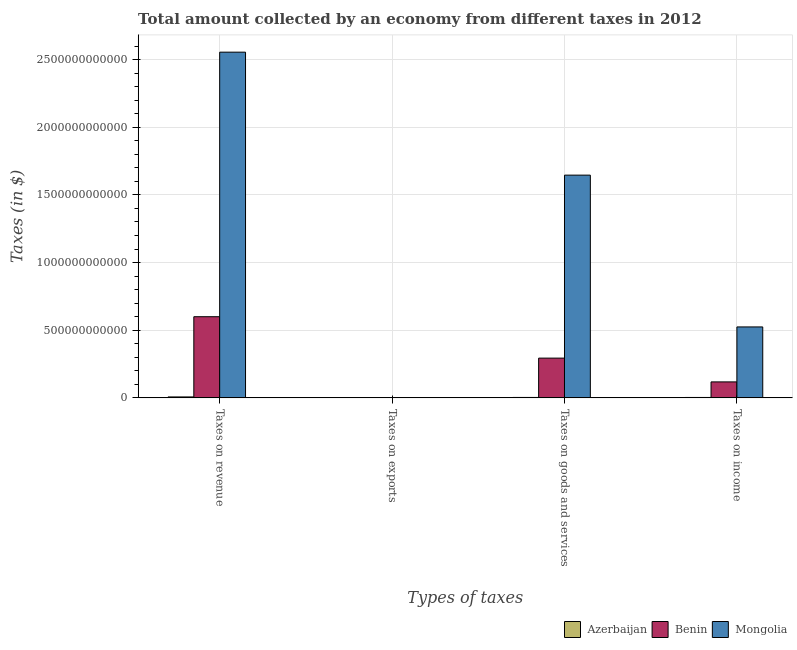How many different coloured bars are there?
Provide a succinct answer. 3. What is the label of the 4th group of bars from the left?
Ensure brevity in your answer.  Taxes on income. What is the amount collected as tax on exports in Azerbaijan?
Provide a short and direct response. 8.00e+05. Across all countries, what is the maximum amount collected as tax on exports?
Your answer should be compact. 4.79e+08. Across all countries, what is the minimum amount collected as tax on revenue?
Provide a succinct answer. 7.00e+09. In which country was the amount collected as tax on income maximum?
Offer a very short reply. Mongolia. In which country was the amount collected as tax on revenue minimum?
Ensure brevity in your answer.  Azerbaijan. What is the total amount collected as tax on income in the graph?
Offer a very short reply. 6.46e+11. What is the difference between the amount collected as tax on exports in Benin and that in Mongolia?
Provide a short and direct response. 2.84e+08. What is the difference between the amount collected as tax on income in Mongolia and the amount collected as tax on goods in Azerbaijan?
Provide a succinct answer. 5.21e+11. What is the average amount collected as tax on goods per country?
Give a very brief answer. 6.48e+11. What is the difference between the amount collected as tax on goods and amount collected as tax on exports in Benin?
Your answer should be compact. 2.93e+11. In how many countries, is the amount collected as tax on goods greater than 1700000000000 $?
Your response must be concise. 0. What is the ratio of the amount collected as tax on revenue in Benin to that in Azerbaijan?
Your answer should be compact. 85.76. Is the amount collected as tax on income in Benin less than that in Mongolia?
Provide a short and direct response. Yes. What is the difference between the highest and the second highest amount collected as tax on revenue?
Provide a succinct answer. 1.96e+12. What is the difference between the highest and the lowest amount collected as tax on exports?
Make the answer very short. 4.79e+08. Is the sum of the amount collected as tax on exports in Benin and Azerbaijan greater than the maximum amount collected as tax on income across all countries?
Offer a very short reply. No. What does the 3rd bar from the left in Taxes on income represents?
Give a very brief answer. Mongolia. What does the 3rd bar from the right in Taxes on exports represents?
Your answer should be very brief. Azerbaijan. Is it the case that in every country, the sum of the amount collected as tax on revenue and amount collected as tax on exports is greater than the amount collected as tax on goods?
Your response must be concise. Yes. How many countries are there in the graph?
Provide a short and direct response. 3. What is the difference between two consecutive major ticks on the Y-axis?
Ensure brevity in your answer.  5.00e+11. Are the values on the major ticks of Y-axis written in scientific E-notation?
Your answer should be very brief. No. Does the graph contain any zero values?
Your answer should be very brief. No. Does the graph contain grids?
Provide a short and direct response. Yes. How many legend labels are there?
Ensure brevity in your answer.  3. What is the title of the graph?
Make the answer very short. Total amount collected by an economy from different taxes in 2012. What is the label or title of the X-axis?
Keep it short and to the point. Types of taxes. What is the label or title of the Y-axis?
Provide a short and direct response. Taxes (in $). What is the Taxes (in $) in Azerbaijan in Taxes on revenue?
Your answer should be compact. 7.00e+09. What is the Taxes (in $) in Benin in Taxes on revenue?
Give a very brief answer. 6.00e+11. What is the Taxes (in $) in Mongolia in Taxes on revenue?
Ensure brevity in your answer.  2.56e+12. What is the Taxes (in $) in Benin in Taxes on exports?
Ensure brevity in your answer.  4.79e+08. What is the Taxes (in $) of Mongolia in Taxes on exports?
Give a very brief answer. 1.95e+08. What is the Taxes (in $) in Azerbaijan in Taxes on goods and services?
Ensure brevity in your answer.  3.08e+09. What is the Taxes (in $) of Benin in Taxes on goods and services?
Your answer should be very brief. 2.94e+11. What is the Taxes (in $) of Mongolia in Taxes on goods and services?
Provide a succinct answer. 1.65e+12. What is the Taxes (in $) of Azerbaijan in Taxes on income?
Offer a very short reply. 3.07e+09. What is the Taxes (in $) of Benin in Taxes on income?
Your response must be concise. 1.18e+11. What is the Taxes (in $) in Mongolia in Taxes on income?
Provide a succinct answer. 5.24e+11. Across all Types of taxes, what is the maximum Taxes (in $) in Azerbaijan?
Give a very brief answer. 7.00e+09. Across all Types of taxes, what is the maximum Taxes (in $) of Benin?
Your response must be concise. 6.00e+11. Across all Types of taxes, what is the maximum Taxes (in $) of Mongolia?
Your answer should be compact. 2.56e+12. Across all Types of taxes, what is the minimum Taxes (in $) of Benin?
Offer a terse response. 4.79e+08. Across all Types of taxes, what is the minimum Taxes (in $) in Mongolia?
Keep it short and to the point. 1.95e+08. What is the total Taxes (in $) of Azerbaijan in the graph?
Give a very brief answer. 1.31e+1. What is the total Taxes (in $) of Benin in the graph?
Give a very brief answer. 1.01e+12. What is the total Taxes (in $) of Mongolia in the graph?
Provide a succinct answer. 4.73e+12. What is the difference between the Taxes (in $) of Azerbaijan in Taxes on revenue and that in Taxes on exports?
Your answer should be very brief. 6.99e+09. What is the difference between the Taxes (in $) of Benin in Taxes on revenue and that in Taxes on exports?
Provide a succinct answer. 5.99e+11. What is the difference between the Taxes (in $) in Mongolia in Taxes on revenue and that in Taxes on exports?
Make the answer very short. 2.56e+12. What is the difference between the Taxes (in $) of Azerbaijan in Taxes on revenue and that in Taxes on goods and services?
Your answer should be very brief. 3.92e+09. What is the difference between the Taxes (in $) of Benin in Taxes on revenue and that in Taxes on goods and services?
Offer a terse response. 3.06e+11. What is the difference between the Taxes (in $) of Mongolia in Taxes on revenue and that in Taxes on goods and services?
Offer a very short reply. 9.09e+11. What is the difference between the Taxes (in $) of Azerbaijan in Taxes on revenue and that in Taxes on income?
Your answer should be very brief. 3.92e+09. What is the difference between the Taxes (in $) of Benin in Taxes on revenue and that in Taxes on income?
Provide a succinct answer. 4.82e+11. What is the difference between the Taxes (in $) in Mongolia in Taxes on revenue and that in Taxes on income?
Your answer should be very brief. 2.03e+12. What is the difference between the Taxes (in $) of Azerbaijan in Taxes on exports and that in Taxes on goods and services?
Your response must be concise. -3.08e+09. What is the difference between the Taxes (in $) in Benin in Taxes on exports and that in Taxes on goods and services?
Provide a short and direct response. -2.93e+11. What is the difference between the Taxes (in $) of Mongolia in Taxes on exports and that in Taxes on goods and services?
Keep it short and to the point. -1.65e+12. What is the difference between the Taxes (in $) of Azerbaijan in Taxes on exports and that in Taxes on income?
Provide a succinct answer. -3.07e+09. What is the difference between the Taxes (in $) of Benin in Taxes on exports and that in Taxes on income?
Ensure brevity in your answer.  -1.18e+11. What is the difference between the Taxes (in $) of Mongolia in Taxes on exports and that in Taxes on income?
Give a very brief answer. -5.24e+11. What is the difference between the Taxes (in $) of Azerbaijan in Taxes on goods and services and that in Taxes on income?
Make the answer very short. 7.40e+06. What is the difference between the Taxes (in $) of Benin in Taxes on goods and services and that in Taxes on income?
Give a very brief answer. 1.76e+11. What is the difference between the Taxes (in $) of Mongolia in Taxes on goods and services and that in Taxes on income?
Make the answer very short. 1.12e+12. What is the difference between the Taxes (in $) of Azerbaijan in Taxes on revenue and the Taxes (in $) of Benin in Taxes on exports?
Provide a short and direct response. 6.52e+09. What is the difference between the Taxes (in $) in Azerbaijan in Taxes on revenue and the Taxes (in $) in Mongolia in Taxes on exports?
Provide a succinct answer. 6.80e+09. What is the difference between the Taxes (in $) in Benin in Taxes on revenue and the Taxes (in $) in Mongolia in Taxes on exports?
Provide a short and direct response. 6.00e+11. What is the difference between the Taxes (in $) in Azerbaijan in Taxes on revenue and the Taxes (in $) in Benin in Taxes on goods and services?
Offer a very short reply. -2.87e+11. What is the difference between the Taxes (in $) of Azerbaijan in Taxes on revenue and the Taxes (in $) of Mongolia in Taxes on goods and services?
Your answer should be compact. -1.64e+12. What is the difference between the Taxes (in $) of Benin in Taxes on revenue and the Taxes (in $) of Mongolia in Taxes on goods and services?
Your answer should be compact. -1.05e+12. What is the difference between the Taxes (in $) in Azerbaijan in Taxes on revenue and the Taxes (in $) in Benin in Taxes on income?
Provide a short and direct response. -1.11e+11. What is the difference between the Taxes (in $) of Azerbaijan in Taxes on revenue and the Taxes (in $) of Mongolia in Taxes on income?
Your response must be concise. -5.17e+11. What is the difference between the Taxes (in $) of Benin in Taxes on revenue and the Taxes (in $) of Mongolia in Taxes on income?
Keep it short and to the point. 7.55e+1. What is the difference between the Taxes (in $) of Azerbaijan in Taxes on exports and the Taxes (in $) of Benin in Taxes on goods and services?
Give a very brief answer. -2.94e+11. What is the difference between the Taxes (in $) of Azerbaijan in Taxes on exports and the Taxes (in $) of Mongolia in Taxes on goods and services?
Your response must be concise. -1.65e+12. What is the difference between the Taxes (in $) in Benin in Taxes on exports and the Taxes (in $) in Mongolia in Taxes on goods and services?
Provide a short and direct response. -1.65e+12. What is the difference between the Taxes (in $) in Azerbaijan in Taxes on exports and the Taxes (in $) in Benin in Taxes on income?
Your answer should be compact. -1.18e+11. What is the difference between the Taxes (in $) in Azerbaijan in Taxes on exports and the Taxes (in $) in Mongolia in Taxes on income?
Provide a short and direct response. -5.24e+11. What is the difference between the Taxes (in $) of Benin in Taxes on exports and the Taxes (in $) of Mongolia in Taxes on income?
Offer a very short reply. -5.24e+11. What is the difference between the Taxes (in $) in Azerbaijan in Taxes on goods and services and the Taxes (in $) in Benin in Taxes on income?
Give a very brief answer. -1.15e+11. What is the difference between the Taxes (in $) in Azerbaijan in Taxes on goods and services and the Taxes (in $) in Mongolia in Taxes on income?
Provide a succinct answer. -5.21e+11. What is the difference between the Taxes (in $) of Benin in Taxes on goods and services and the Taxes (in $) of Mongolia in Taxes on income?
Make the answer very short. -2.31e+11. What is the average Taxes (in $) of Azerbaijan per Types of taxes?
Give a very brief answer. 3.29e+09. What is the average Taxes (in $) of Benin per Types of taxes?
Your response must be concise. 2.53e+11. What is the average Taxes (in $) of Mongolia per Types of taxes?
Provide a succinct answer. 1.18e+12. What is the difference between the Taxes (in $) of Azerbaijan and Taxes (in $) of Benin in Taxes on revenue?
Ensure brevity in your answer.  -5.93e+11. What is the difference between the Taxes (in $) in Azerbaijan and Taxes (in $) in Mongolia in Taxes on revenue?
Provide a succinct answer. -2.55e+12. What is the difference between the Taxes (in $) of Benin and Taxes (in $) of Mongolia in Taxes on revenue?
Your response must be concise. -1.96e+12. What is the difference between the Taxes (in $) of Azerbaijan and Taxes (in $) of Benin in Taxes on exports?
Make the answer very short. -4.79e+08. What is the difference between the Taxes (in $) of Azerbaijan and Taxes (in $) of Mongolia in Taxes on exports?
Your answer should be compact. -1.94e+08. What is the difference between the Taxes (in $) of Benin and Taxes (in $) of Mongolia in Taxes on exports?
Your answer should be compact. 2.84e+08. What is the difference between the Taxes (in $) in Azerbaijan and Taxes (in $) in Benin in Taxes on goods and services?
Give a very brief answer. -2.91e+11. What is the difference between the Taxes (in $) in Azerbaijan and Taxes (in $) in Mongolia in Taxes on goods and services?
Your answer should be compact. -1.64e+12. What is the difference between the Taxes (in $) in Benin and Taxes (in $) in Mongolia in Taxes on goods and services?
Provide a short and direct response. -1.35e+12. What is the difference between the Taxes (in $) in Azerbaijan and Taxes (in $) in Benin in Taxes on income?
Your answer should be compact. -1.15e+11. What is the difference between the Taxes (in $) of Azerbaijan and Taxes (in $) of Mongolia in Taxes on income?
Your answer should be very brief. -5.21e+11. What is the difference between the Taxes (in $) in Benin and Taxes (in $) in Mongolia in Taxes on income?
Offer a terse response. -4.06e+11. What is the ratio of the Taxes (in $) of Azerbaijan in Taxes on revenue to that in Taxes on exports?
Make the answer very short. 8744.38. What is the ratio of the Taxes (in $) in Benin in Taxes on revenue to that in Taxes on exports?
Give a very brief answer. 1251.49. What is the ratio of the Taxes (in $) of Mongolia in Taxes on revenue to that in Taxes on exports?
Offer a terse response. 1.31e+04. What is the ratio of the Taxes (in $) of Azerbaijan in Taxes on revenue to that in Taxes on goods and services?
Your answer should be very brief. 2.27. What is the ratio of the Taxes (in $) of Benin in Taxes on revenue to that in Taxes on goods and services?
Give a very brief answer. 2.04. What is the ratio of the Taxes (in $) in Mongolia in Taxes on revenue to that in Taxes on goods and services?
Provide a short and direct response. 1.55. What is the ratio of the Taxes (in $) in Azerbaijan in Taxes on revenue to that in Taxes on income?
Ensure brevity in your answer.  2.28. What is the ratio of the Taxes (in $) of Benin in Taxes on revenue to that in Taxes on income?
Your answer should be compact. 5.08. What is the ratio of the Taxes (in $) of Mongolia in Taxes on revenue to that in Taxes on income?
Your response must be concise. 4.87. What is the ratio of the Taxes (in $) in Azerbaijan in Taxes on exports to that in Taxes on goods and services?
Your answer should be compact. 0. What is the ratio of the Taxes (in $) in Benin in Taxes on exports to that in Taxes on goods and services?
Keep it short and to the point. 0. What is the ratio of the Taxes (in $) in Mongolia in Taxes on exports to that in Taxes on goods and services?
Offer a very short reply. 0. What is the ratio of the Taxes (in $) of Azerbaijan in Taxes on exports to that in Taxes on income?
Keep it short and to the point. 0. What is the ratio of the Taxes (in $) in Benin in Taxes on exports to that in Taxes on income?
Offer a very short reply. 0. What is the ratio of the Taxes (in $) in Azerbaijan in Taxes on goods and services to that in Taxes on income?
Offer a terse response. 1. What is the ratio of the Taxes (in $) of Benin in Taxes on goods and services to that in Taxes on income?
Make the answer very short. 2.49. What is the ratio of the Taxes (in $) in Mongolia in Taxes on goods and services to that in Taxes on income?
Offer a terse response. 3.14. What is the difference between the highest and the second highest Taxes (in $) in Azerbaijan?
Offer a terse response. 3.92e+09. What is the difference between the highest and the second highest Taxes (in $) in Benin?
Offer a very short reply. 3.06e+11. What is the difference between the highest and the second highest Taxes (in $) in Mongolia?
Make the answer very short. 9.09e+11. What is the difference between the highest and the lowest Taxes (in $) of Azerbaijan?
Make the answer very short. 6.99e+09. What is the difference between the highest and the lowest Taxes (in $) in Benin?
Provide a short and direct response. 5.99e+11. What is the difference between the highest and the lowest Taxes (in $) of Mongolia?
Offer a terse response. 2.56e+12. 